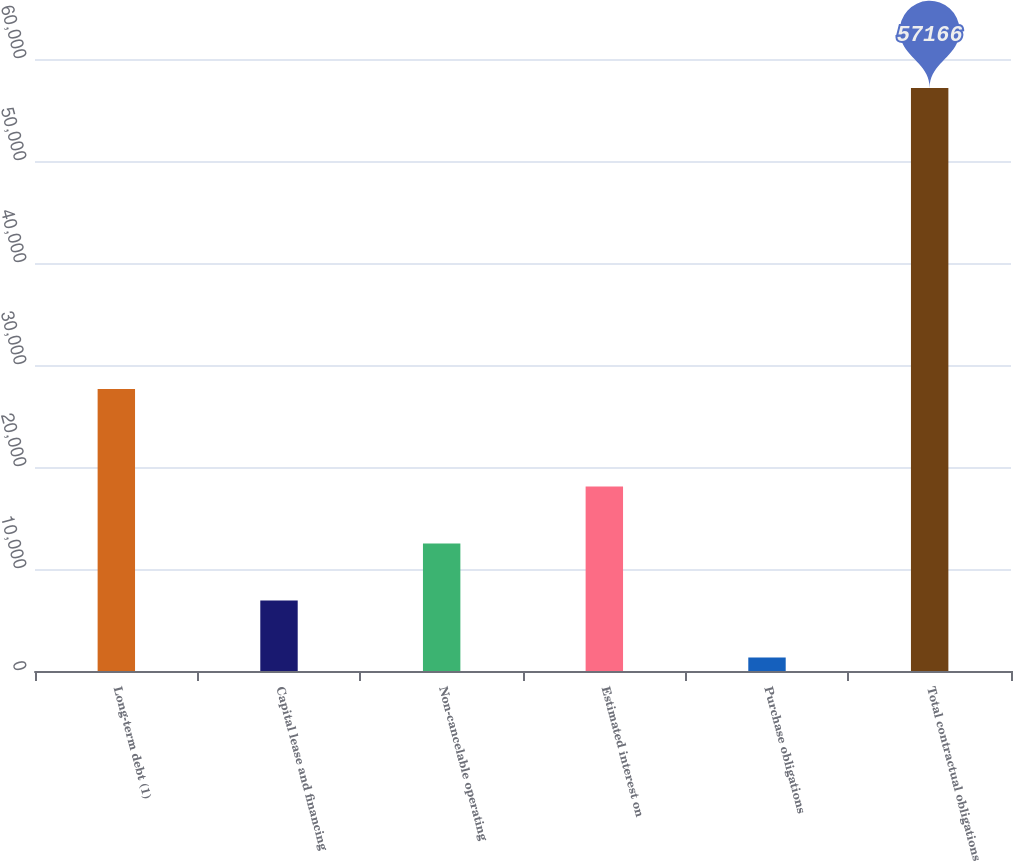<chart> <loc_0><loc_0><loc_500><loc_500><bar_chart><fcel>Long-term debt (1)<fcel>Capital lease and financing<fcel>Non-cancelable operating<fcel>Estimated interest on<fcel>Purchase obligations<fcel>Total contractual obligations<nl><fcel>27654<fcel>6911.8<fcel>12495.6<fcel>18079.4<fcel>1328<fcel>57166<nl></chart> 